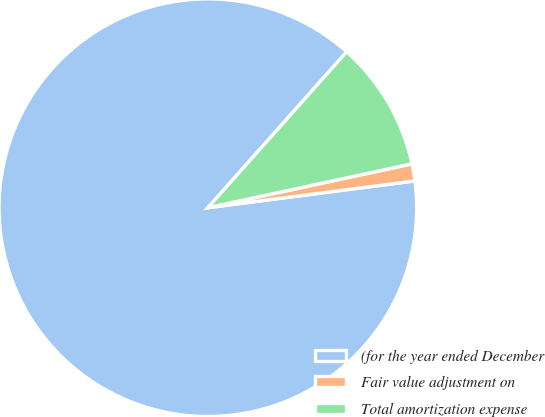<chart> <loc_0><loc_0><loc_500><loc_500><pie_chart><fcel>(for the year ended December<fcel>Fair value adjustment on<fcel>Total amortization expense<nl><fcel>88.62%<fcel>1.32%<fcel>10.05%<nl></chart> 